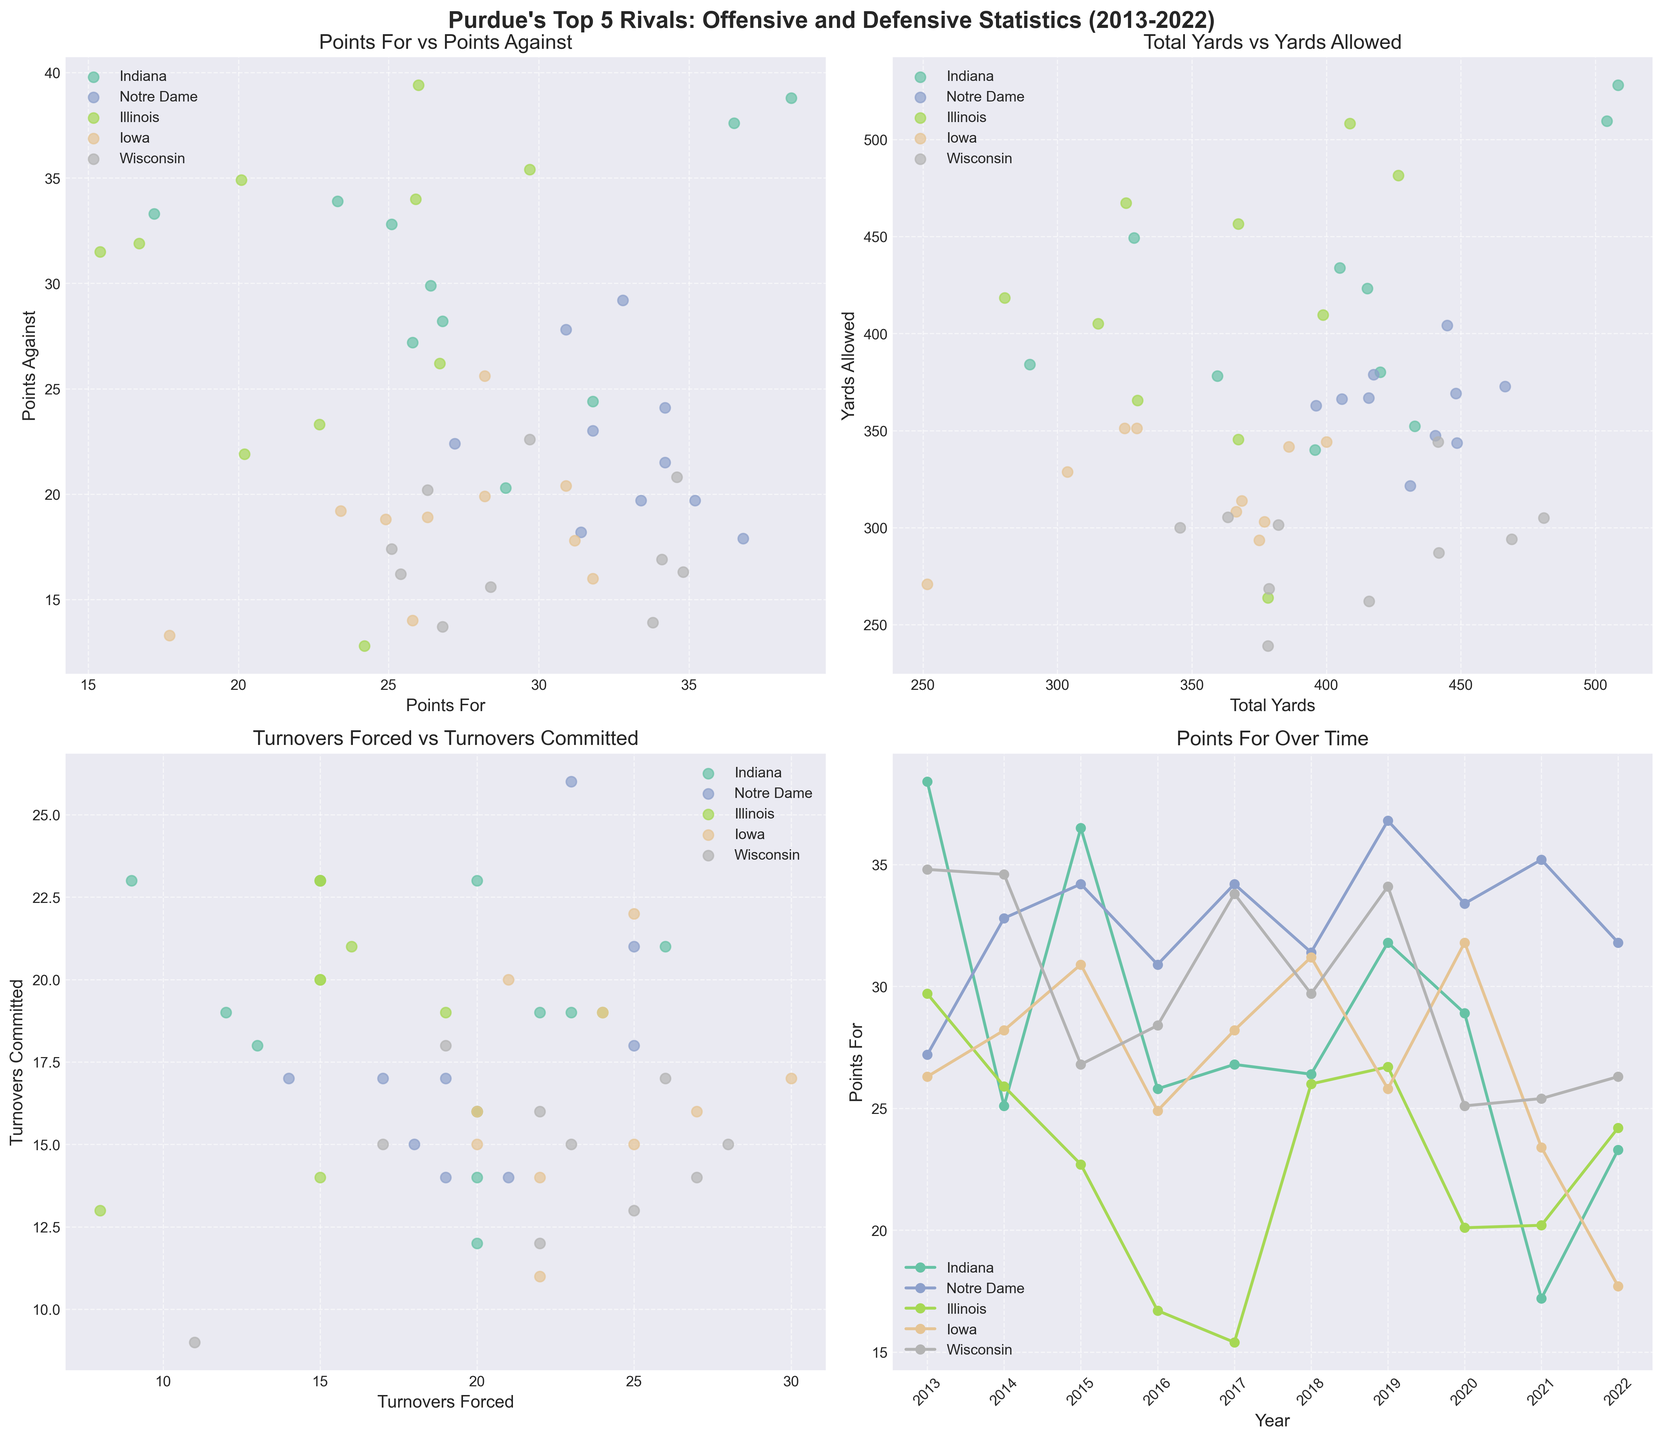Which team has the highest number of turnovers forced while having the least number of turnovers committed? Based on the third subplot, Wisconsin has both the highest number of turnovers forced and the fewest turnovers committed points plotted near the top left of the scatter plot.
Answer: Wisconsin Which two teams have the most contrasting Total Yards and Yards Allowed values in the entire dataset? In the second subplot, Illinois and Wisconsin are positioned at opposing ends of the scatter plot. Illinois has high Yards Allowed values and Wisconsin has comparatively low Yards Allowed values.
Answer: Illinois and Wisconsin How did the Points For for Iowa change from 2013 to 2022? Referring to the fourth subplot, Iowa's Points For fluctuated over time but generally stayed in the mid-20s range, with a peak and drop in between. In 2013, it was around 26.3 and in 2022 it was around 17.7.
Answer: Decreased Between Indiana and Iowa, which team had a higher median Points Against over the decade? In the first subplot, median values require identifying mid-point values. Indiana consistently plots higher than Iowa in the Points Against attribute. Thus, Indiana has a higher median Points Against.
Answer: Indiana What is the general trend in Points For over time for Notre Dame? In the fourth subplot, Notre Dame's Points For line shows a generally increasing trend over time, with some fluctuations but overall an upward trajectory especially peaking around 2019.
Answer: Increasing Which team had the lowest Total Yards in a given year and in which year did this occur? Referring to the second subplot, Illinois in 2017 had points plotted at the lowest value on the x-axis indicating the year with the least Total Yards.
Answer: Illinois, 2017 How do the Turnovers Forced and Turnovers Committed compare between Indiana and Illinois? In the third subplot, Indiana has more varied values in both attributes, whereas Illinois consistently plots lower in Turnovers Forced, thus Indiana generally has more scattered data across higher values.
Answer: Indiana forces more and commits more turnovers Analyzing the Points For and Points Against, which team generally had a more effective defense relative to offense? Observing the first subplot, Wisconsin's plots show lower Points Against compared to its Points For, indicating a more effective defensive performance in relation to its offense.
Answer: Wisconsin Which team shows the highest variability in Points For over time? The fourth subplot indicates Point For over time; Indiana shows dots from low to the high side, meaning high variability in Points For across the years.
Answer: Indiana 